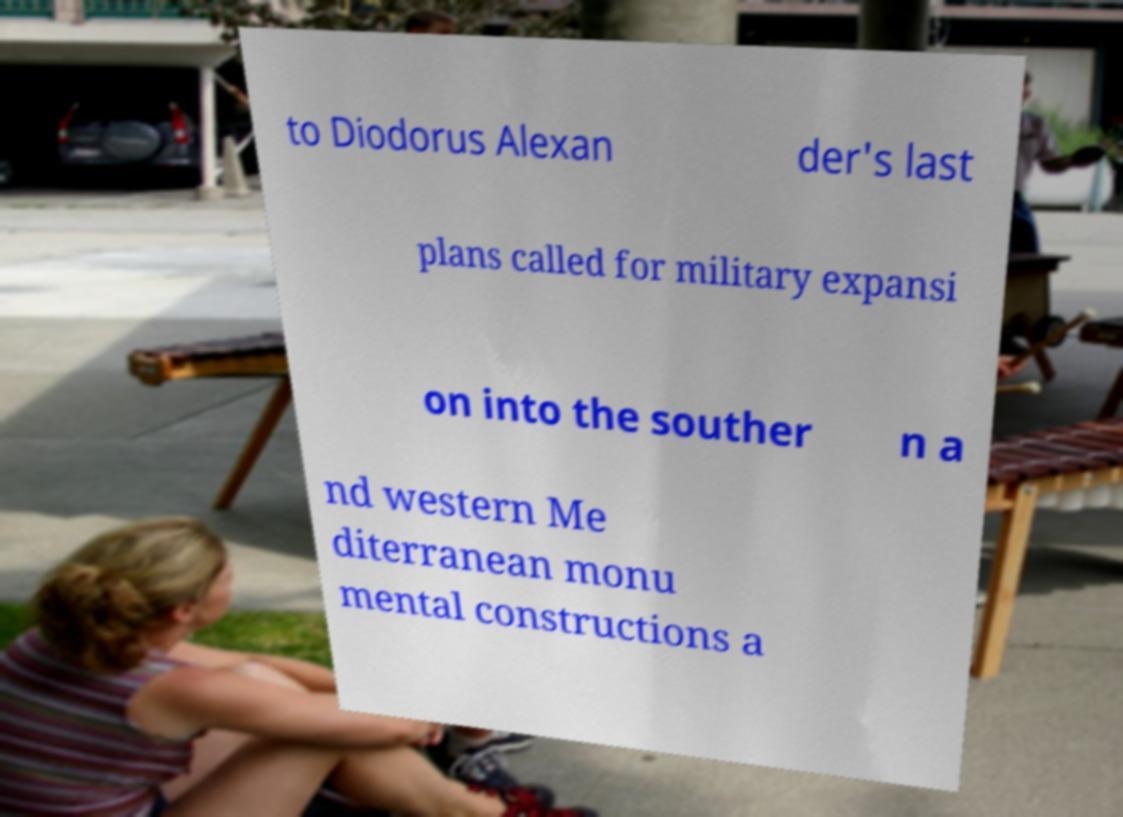Can you accurately transcribe the text from the provided image for me? to Diodorus Alexan der's last plans called for military expansi on into the souther n a nd western Me diterranean monu mental constructions a 